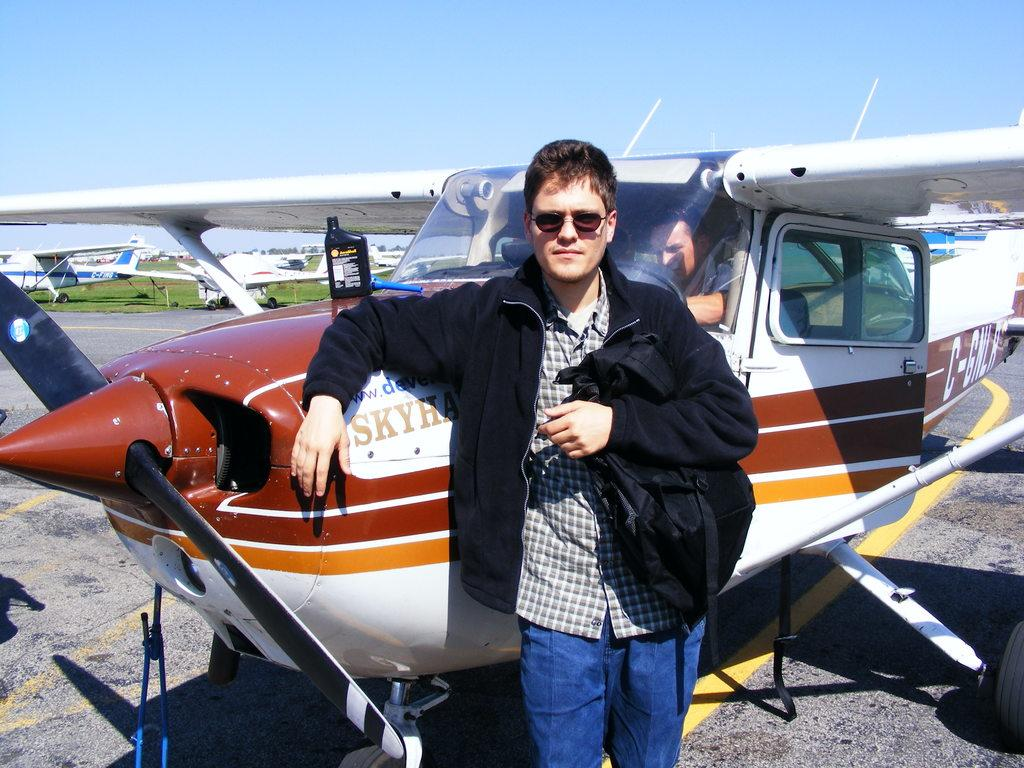What is the main subject of the image? The main subject of the image is planes. Can you describe the person in the image? One person is standing next to a plane, and they are holding a bag. What type of alarm can be heard going off in the image? There is no alarm present in the image, and therefore no such sound can be heard. 